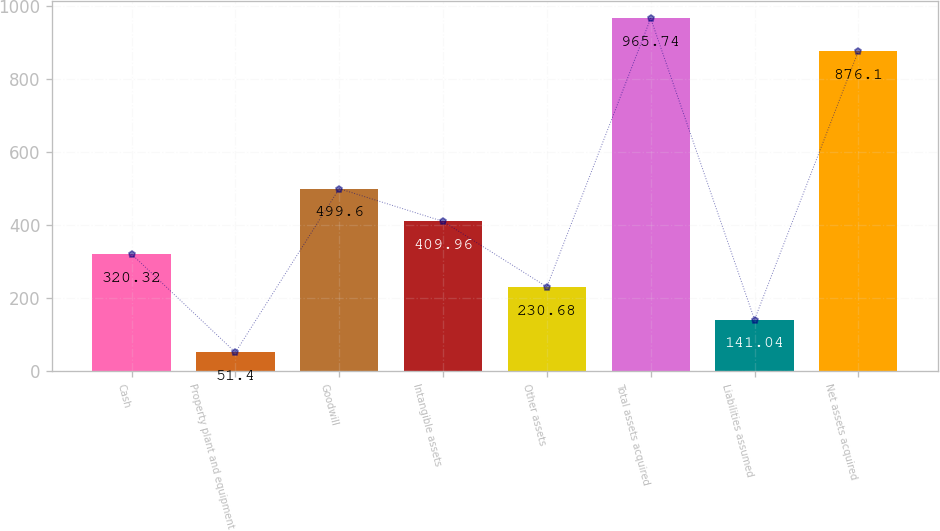Convert chart to OTSL. <chart><loc_0><loc_0><loc_500><loc_500><bar_chart><fcel>Cash<fcel>Property plant and equipment<fcel>Goodwill<fcel>Intangible assets<fcel>Other assets<fcel>Total assets acquired<fcel>Liabilities assumed<fcel>Net assets acquired<nl><fcel>320.32<fcel>51.4<fcel>499.6<fcel>409.96<fcel>230.68<fcel>965.74<fcel>141.04<fcel>876.1<nl></chart> 